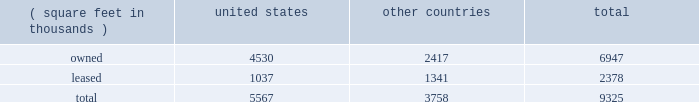Item 2 : properties information concerning applied 2019s properties is set forth below: .
Because of the interrelation of applied 2019s operations , properties within a country may be shared by the segments operating within that country .
The company 2019s headquarters offices are in santa clara , california .
Products in semiconductor systems are manufactured in santa clara , california ; austin , texas ; gloucester , massachusetts ; kalispell , montana ; rehovot , israel ; and singapore .
Remanufactured equipment products in the applied global services segment are produced primarily in austin , texas .
Products in the display and adjacent markets segment are manufactured in alzenau , germany and tainan , taiwan .
Other products are manufactured in treviso , italy .
Applied also owns and leases offices , plants and warehouse locations in many locations throughout the world , including in europe , japan , north america ( principally the united states ) , israel , china , india , korea , southeast asia and taiwan .
These facilities are principally used for manufacturing ; research , development and engineering ; and marketing , sales and customer support .
Applied also owns a total of approximately 269 acres of buildable land in montana , texas , california , israel and italy that could accommodate additional building space .
Applied considers the properties that it owns or leases as adequate to meet its current and future requirements .
Applied regularly assesses the size , capability and location of its global infrastructure and periodically makes adjustments based on these assessments. .
What percentage of buildings are owned in the united states by the company? 
Rationale: to find the percentage of buildings owned by the company in the u.s . one must divide the buildings owned in the u.s . by the total amount of buildings .
Computations: (4530 / 5567)
Answer: 0.81372. 